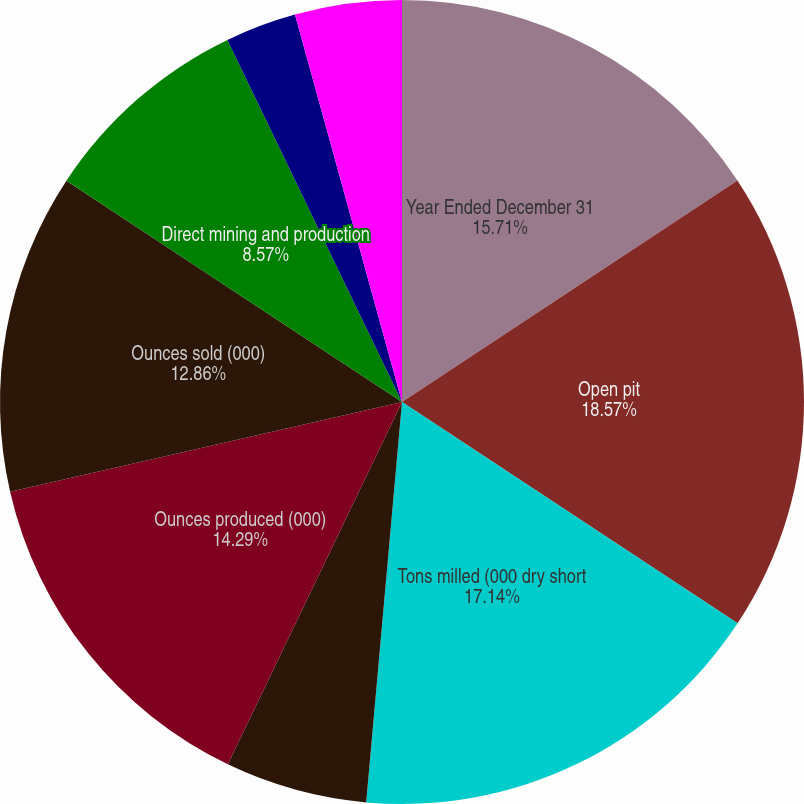<chart> <loc_0><loc_0><loc_500><loc_500><pie_chart><fcel>Year Ended December 31<fcel>Open pit<fcel>Tons milled (000 dry short<fcel>Average ore grade (oz/ton)<fcel>Average mill recovery rate<fcel>Ounces produced (000)<fcel>Ounces sold (000)<fcel>Direct mining and production<fcel>By-product credits<fcel>Royalties and production taxes<nl><fcel>15.71%<fcel>18.57%<fcel>17.14%<fcel>0.0%<fcel>5.71%<fcel>14.29%<fcel>12.86%<fcel>8.57%<fcel>2.86%<fcel>4.29%<nl></chart> 